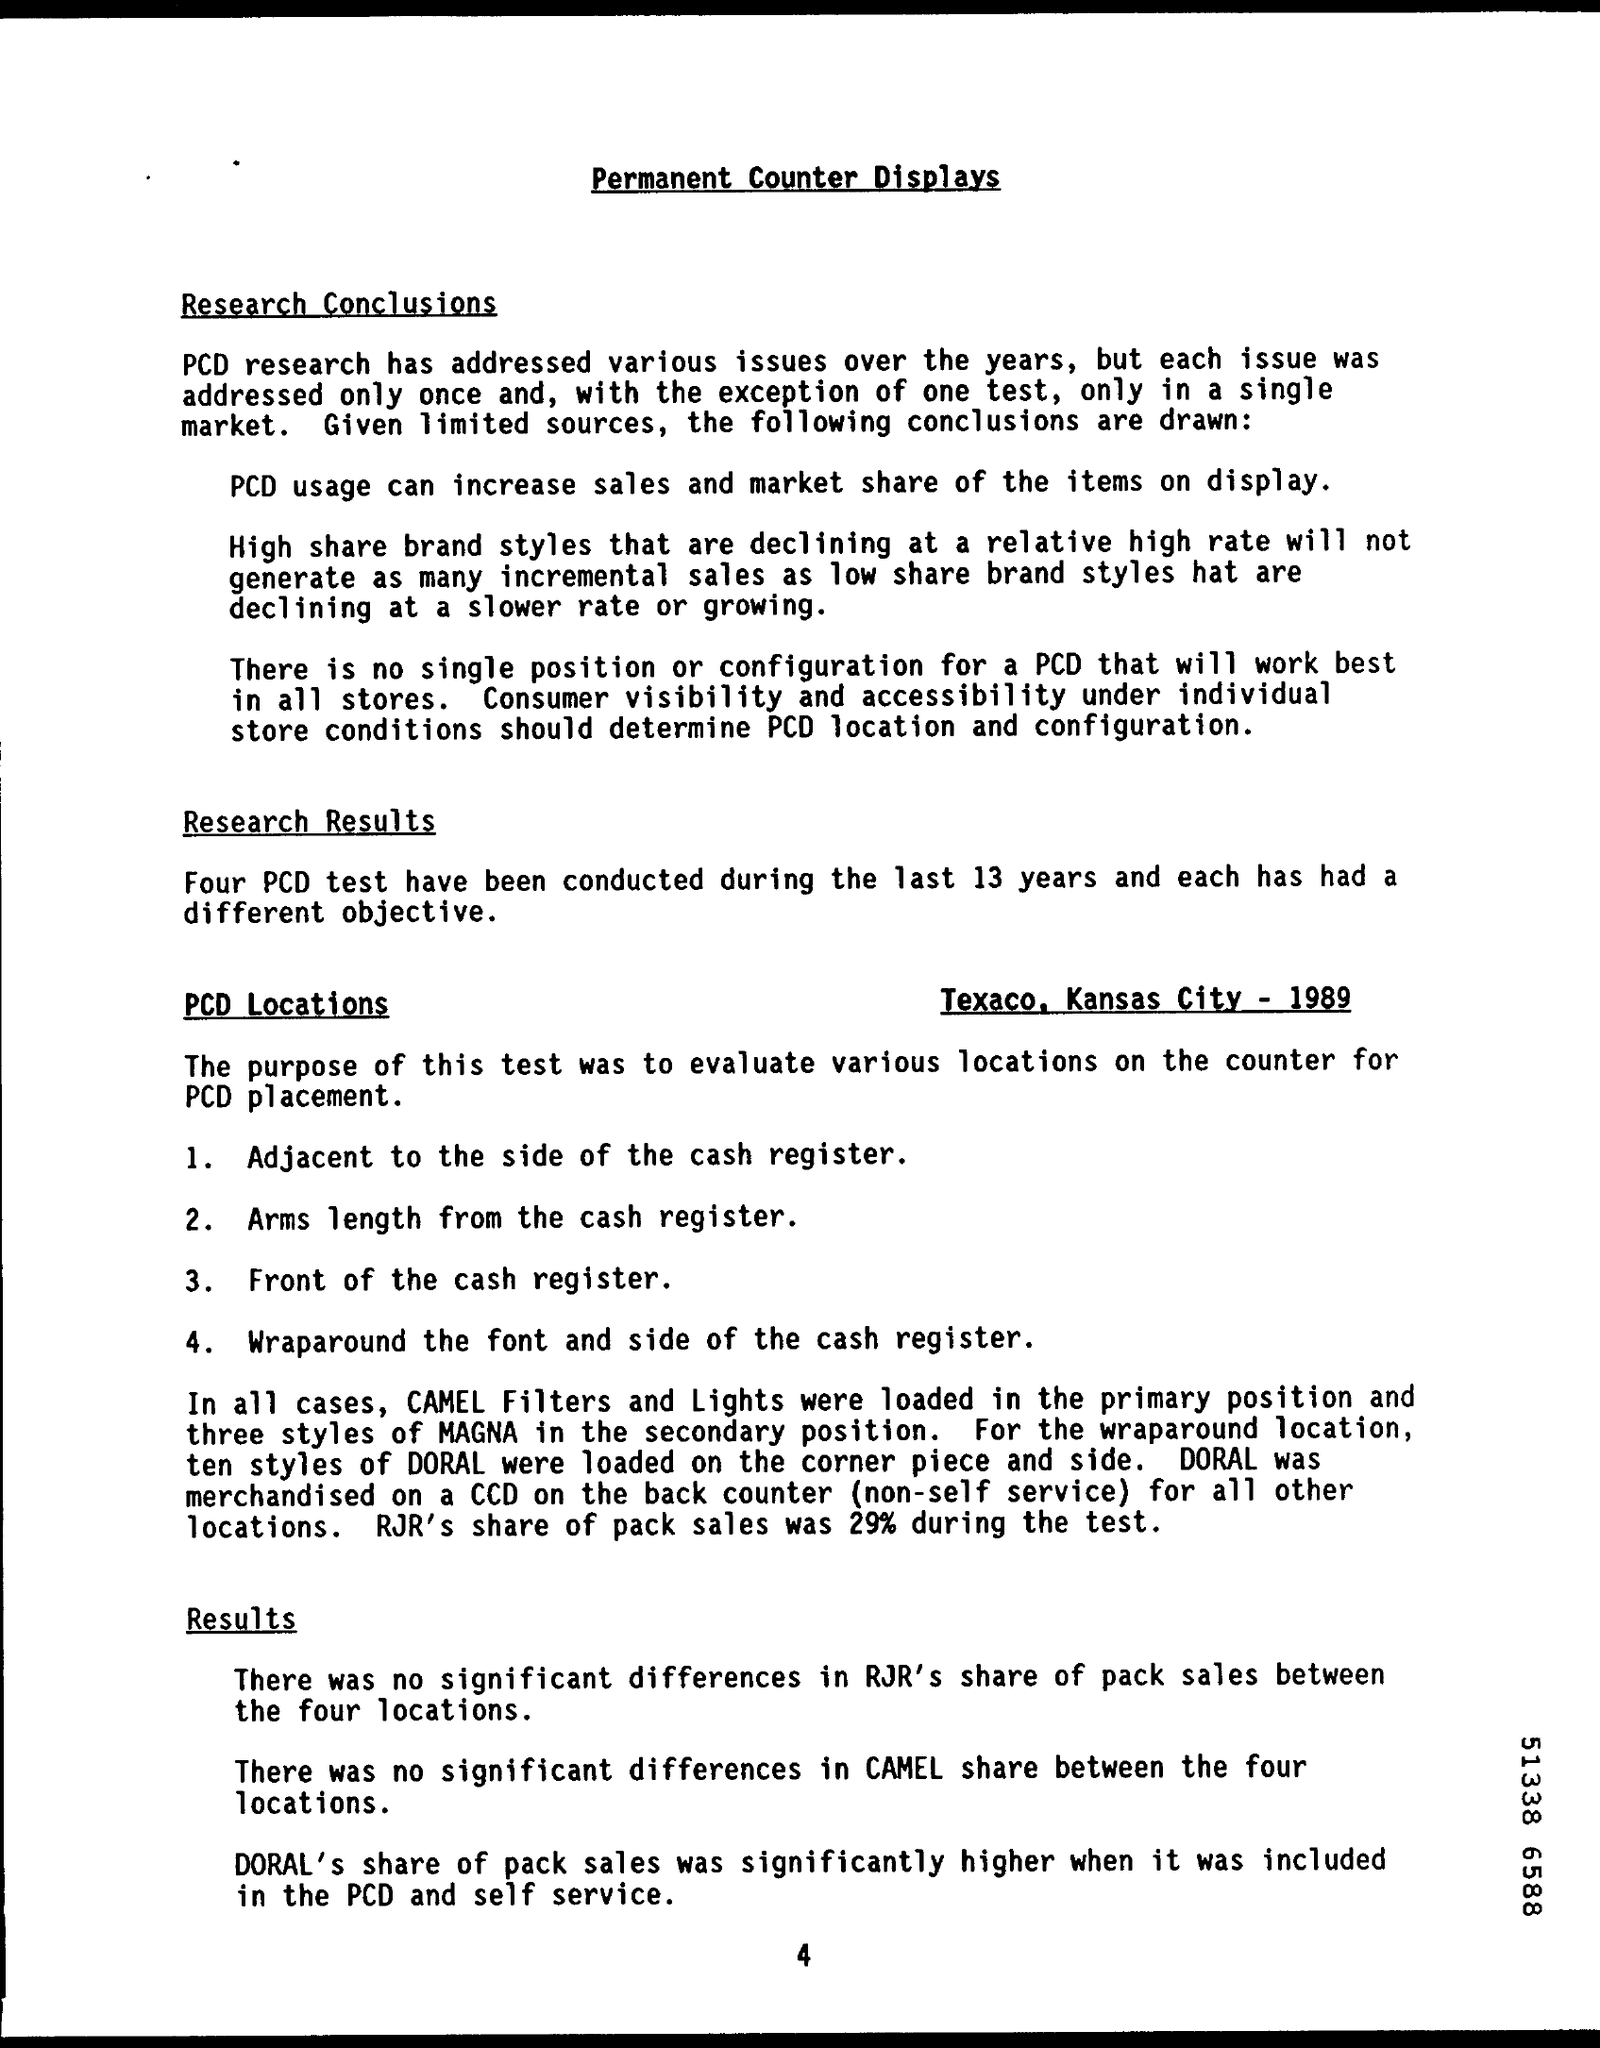What is the document title?
Your response must be concise. Permanent Counter Displays. How many PCD tests have been conducted during the last 13 years?
Provide a short and direct response. Four. What was RJR's share of pack sales during the test?
Give a very brief answer. 29%. Where were the PCD locations?
Keep it short and to the point. Texaco. 